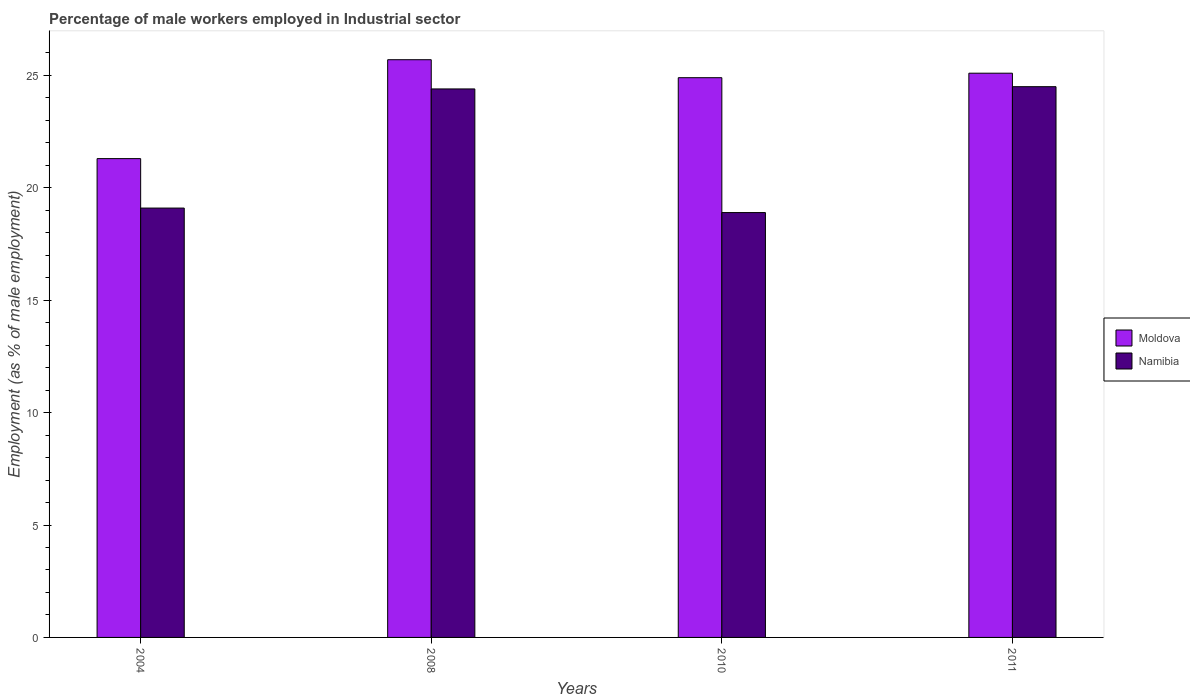How many groups of bars are there?
Keep it short and to the point. 4. Are the number of bars per tick equal to the number of legend labels?
Offer a terse response. Yes. How many bars are there on the 4th tick from the left?
Ensure brevity in your answer.  2. How many bars are there on the 1st tick from the right?
Your response must be concise. 2. What is the percentage of male workers employed in Industrial sector in Namibia in 2010?
Make the answer very short. 18.9. Across all years, what is the minimum percentage of male workers employed in Industrial sector in Namibia?
Give a very brief answer. 18.9. What is the total percentage of male workers employed in Industrial sector in Moldova in the graph?
Ensure brevity in your answer.  97. What is the difference between the percentage of male workers employed in Industrial sector in Moldova in 2008 and that in 2010?
Make the answer very short. 0.8. What is the difference between the percentage of male workers employed in Industrial sector in Namibia in 2011 and the percentage of male workers employed in Industrial sector in Moldova in 2010?
Make the answer very short. -0.4. What is the average percentage of male workers employed in Industrial sector in Moldova per year?
Keep it short and to the point. 24.25. In the year 2011, what is the difference between the percentage of male workers employed in Industrial sector in Moldova and percentage of male workers employed in Industrial sector in Namibia?
Your answer should be compact. 0.6. In how many years, is the percentage of male workers employed in Industrial sector in Moldova greater than 19 %?
Your answer should be very brief. 4. What is the ratio of the percentage of male workers employed in Industrial sector in Moldova in 2010 to that in 2011?
Keep it short and to the point. 0.99. Is the percentage of male workers employed in Industrial sector in Moldova in 2004 less than that in 2010?
Your answer should be very brief. Yes. What is the difference between the highest and the second highest percentage of male workers employed in Industrial sector in Namibia?
Offer a very short reply. 0.1. What is the difference between the highest and the lowest percentage of male workers employed in Industrial sector in Moldova?
Your response must be concise. 4.4. Is the sum of the percentage of male workers employed in Industrial sector in Moldova in 2004 and 2010 greater than the maximum percentage of male workers employed in Industrial sector in Namibia across all years?
Your answer should be compact. Yes. What does the 1st bar from the left in 2011 represents?
Offer a very short reply. Moldova. What does the 1st bar from the right in 2011 represents?
Offer a very short reply. Namibia. How many bars are there?
Provide a short and direct response. 8. Where does the legend appear in the graph?
Keep it short and to the point. Center right. How many legend labels are there?
Offer a terse response. 2. How are the legend labels stacked?
Make the answer very short. Vertical. What is the title of the graph?
Offer a very short reply. Percentage of male workers employed in Industrial sector. Does "Fragile and conflict affected situations" appear as one of the legend labels in the graph?
Offer a very short reply. No. What is the label or title of the Y-axis?
Offer a terse response. Employment (as % of male employment). What is the Employment (as % of male employment) of Moldova in 2004?
Ensure brevity in your answer.  21.3. What is the Employment (as % of male employment) in Namibia in 2004?
Provide a short and direct response. 19.1. What is the Employment (as % of male employment) in Moldova in 2008?
Keep it short and to the point. 25.7. What is the Employment (as % of male employment) of Namibia in 2008?
Keep it short and to the point. 24.4. What is the Employment (as % of male employment) in Moldova in 2010?
Provide a succinct answer. 24.9. What is the Employment (as % of male employment) in Namibia in 2010?
Make the answer very short. 18.9. What is the Employment (as % of male employment) of Moldova in 2011?
Keep it short and to the point. 25.1. What is the Employment (as % of male employment) of Namibia in 2011?
Offer a terse response. 24.5. Across all years, what is the maximum Employment (as % of male employment) in Moldova?
Keep it short and to the point. 25.7. Across all years, what is the minimum Employment (as % of male employment) in Moldova?
Provide a short and direct response. 21.3. Across all years, what is the minimum Employment (as % of male employment) of Namibia?
Your response must be concise. 18.9. What is the total Employment (as % of male employment) of Moldova in the graph?
Your answer should be very brief. 97. What is the total Employment (as % of male employment) in Namibia in the graph?
Offer a terse response. 86.9. What is the difference between the Employment (as % of male employment) in Namibia in 2008 and that in 2011?
Your answer should be compact. -0.1. What is the difference between the Employment (as % of male employment) in Moldova in 2010 and that in 2011?
Give a very brief answer. -0.2. What is the difference between the Employment (as % of male employment) in Moldova in 2010 and the Employment (as % of male employment) in Namibia in 2011?
Keep it short and to the point. 0.4. What is the average Employment (as % of male employment) in Moldova per year?
Your response must be concise. 24.25. What is the average Employment (as % of male employment) in Namibia per year?
Offer a terse response. 21.73. In the year 2004, what is the difference between the Employment (as % of male employment) of Moldova and Employment (as % of male employment) of Namibia?
Ensure brevity in your answer.  2.2. In the year 2008, what is the difference between the Employment (as % of male employment) in Moldova and Employment (as % of male employment) in Namibia?
Your response must be concise. 1.3. What is the ratio of the Employment (as % of male employment) of Moldova in 2004 to that in 2008?
Your answer should be compact. 0.83. What is the ratio of the Employment (as % of male employment) of Namibia in 2004 to that in 2008?
Provide a succinct answer. 0.78. What is the ratio of the Employment (as % of male employment) of Moldova in 2004 to that in 2010?
Your answer should be compact. 0.86. What is the ratio of the Employment (as % of male employment) of Namibia in 2004 to that in 2010?
Give a very brief answer. 1.01. What is the ratio of the Employment (as % of male employment) in Moldova in 2004 to that in 2011?
Your response must be concise. 0.85. What is the ratio of the Employment (as % of male employment) of Namibia in 2004 to that in 2011?
Provide a succinct answer. 0.78. What is the ratio of the Employment (as % of male employment) of Moldova in 2008 to that in 2010?
Make the answer very short. 1.03. What is the ratio of the Employment (as % of male employment) of Namibia in 2008 to that in 2010?
Provide a succinct answer. 1.29. What is the ratio of the Employment (as % of male employment) of Moldova in 2008 to that in 2011?
Your answer should be compact. 1.02. What is the ratio of the Employment (as % of male employment) of Namibia in 2010 to that in 2011?
Keep it short and to the point. 0.77. What is the difference between the highest and the second highest Employment (as % of male employment) of Namibia?
Offer a very short reply. 0.1. What is the difference between the highest and the lowest Employment (as % of male employment) in Moldova?
Make the answer very short. 4.4. 